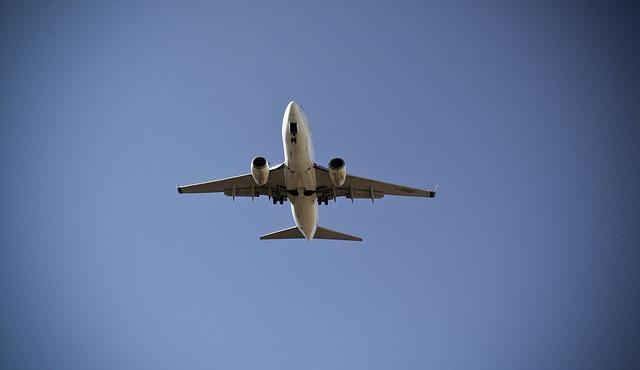How many propellers are on the plane?
Give a very brief answer. 0. How many bus tires can you count?
Give a very brief answer. 0. 